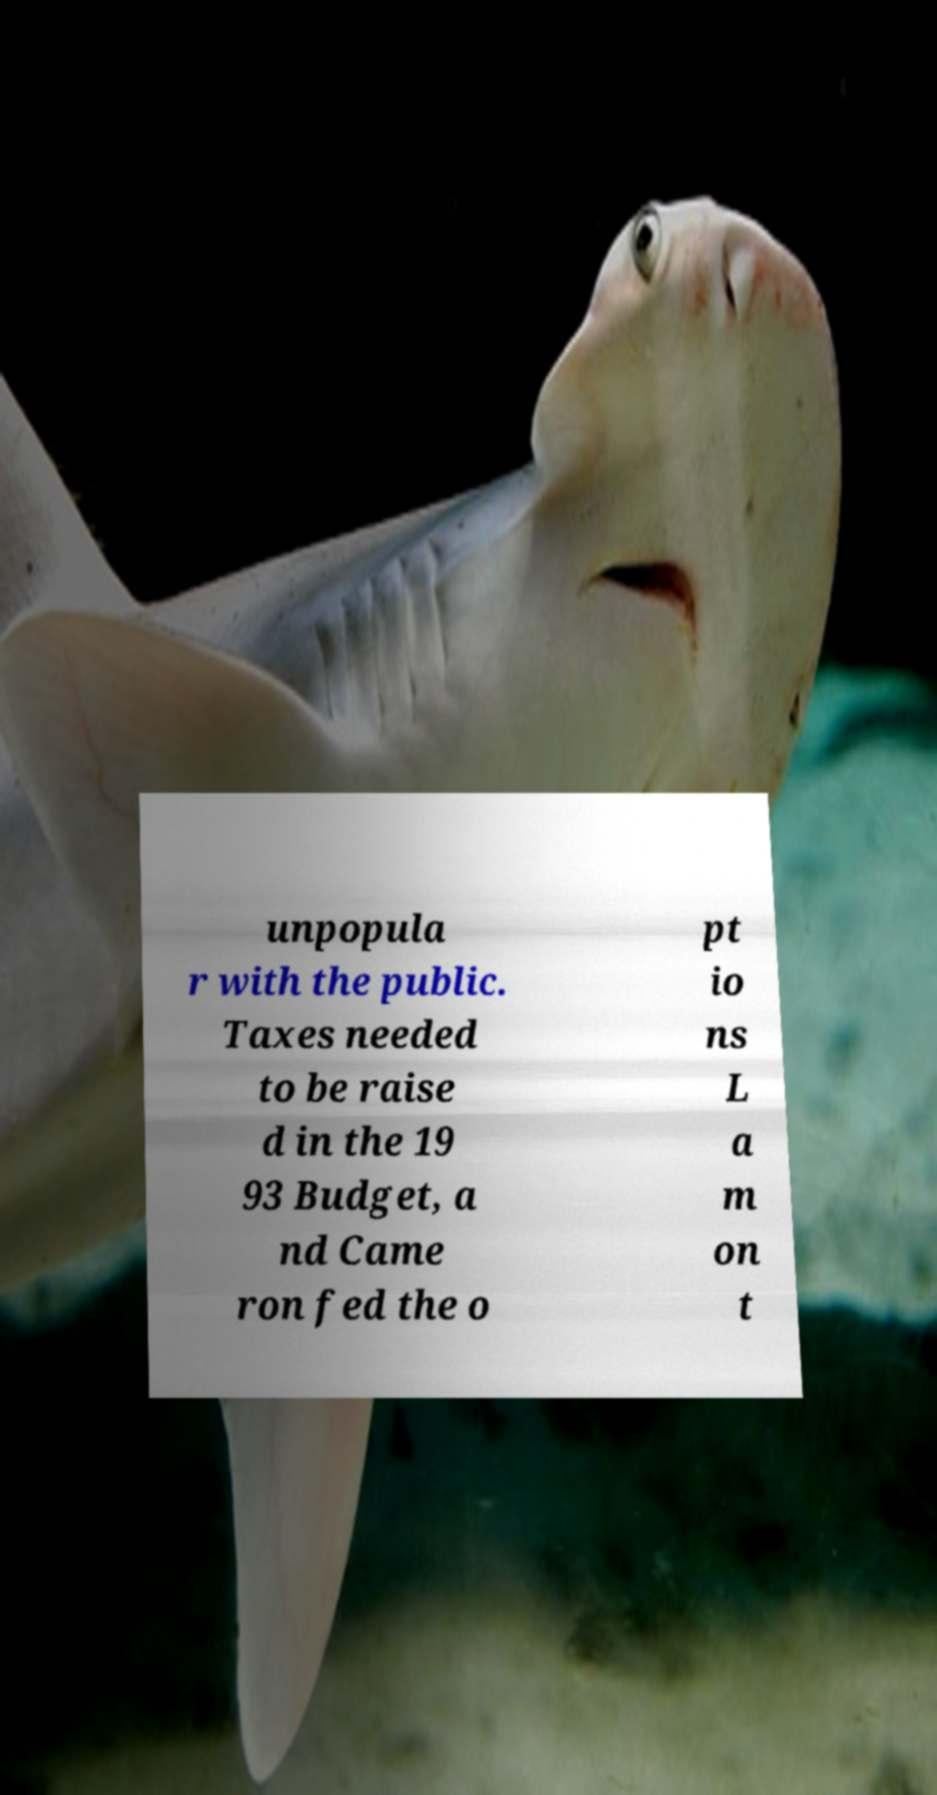I need the written content from this picture converted into text. Can you do that? unpopula r with the public. Taxes needed to be raise d in the 19 93 Budget, a nd Came ron fed the o pt io ns L a m on t 